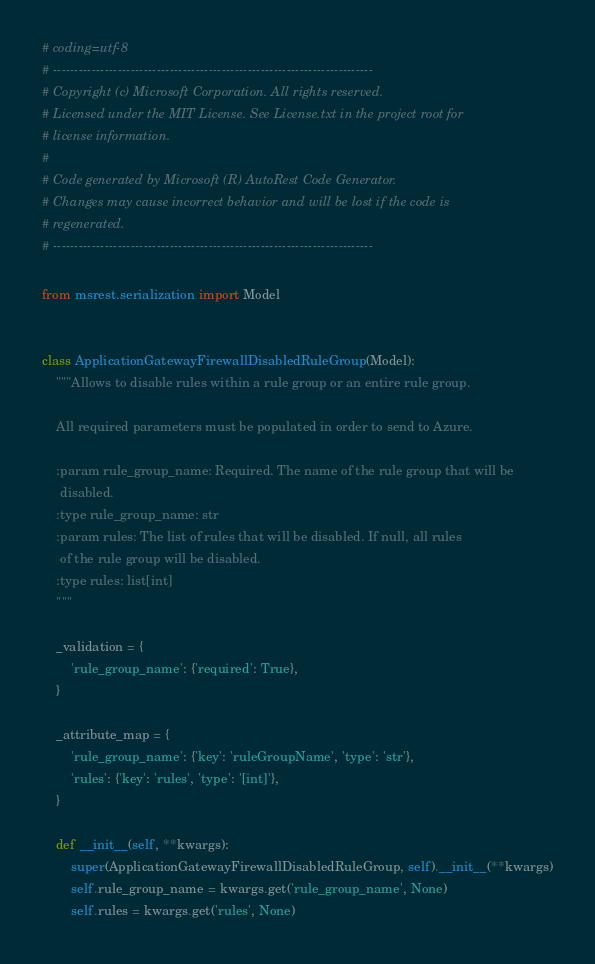<code> <loc_0><loc_0><loc_500><loc_500><_Python_># coding=utf-8
# --------------------------------------------------------------------------
# Copyright (c) Microsoft Corporation. All rights reserved.
# Licensed under the MIT License. See License.txt in the project root for
# license information.
#
# Code generated by Microsoft (R) AutoRest Code Generator.
# Changes may cause incorrect behavior and will be lost if the code is
# regenerated.
# --------------------------------------------------------------------------

from msrest.serialization import Model


class ApplicationGatewayFirewallDisabledRuleGroup(Model):
    """Allows to disable rules within a rule group or an entire rule group.

    All required parameters must be populated in order to send to Azure.

    :param rule_group_name: Required. The name of the rule group that will be
     disabled.
    :type rule_group_name: str
    :param rules: The list of rules that will be disabled. If null, all rules
     of the rule group will be disabled.
    :type rules: list[int]
    """

    _validation = {
        'rule_group_name': {'required': True},
    }

    _attribute_map = {
        'rule_group_name': {'key': 'ruleGroupName', 'type': 'str'},
        'rules': {'key': 'rules', 'type': '[int]'},
    }

    def __init__(self, **kwargs):
        super(ApplicationGatewayFirewallDisabledRuleGroup, self).__init__(**kwargs)
        self.rule_group_name = kwargs.get('rule_group_name', None)
        self.rules = kwargs.get('rules', None)
</code> 